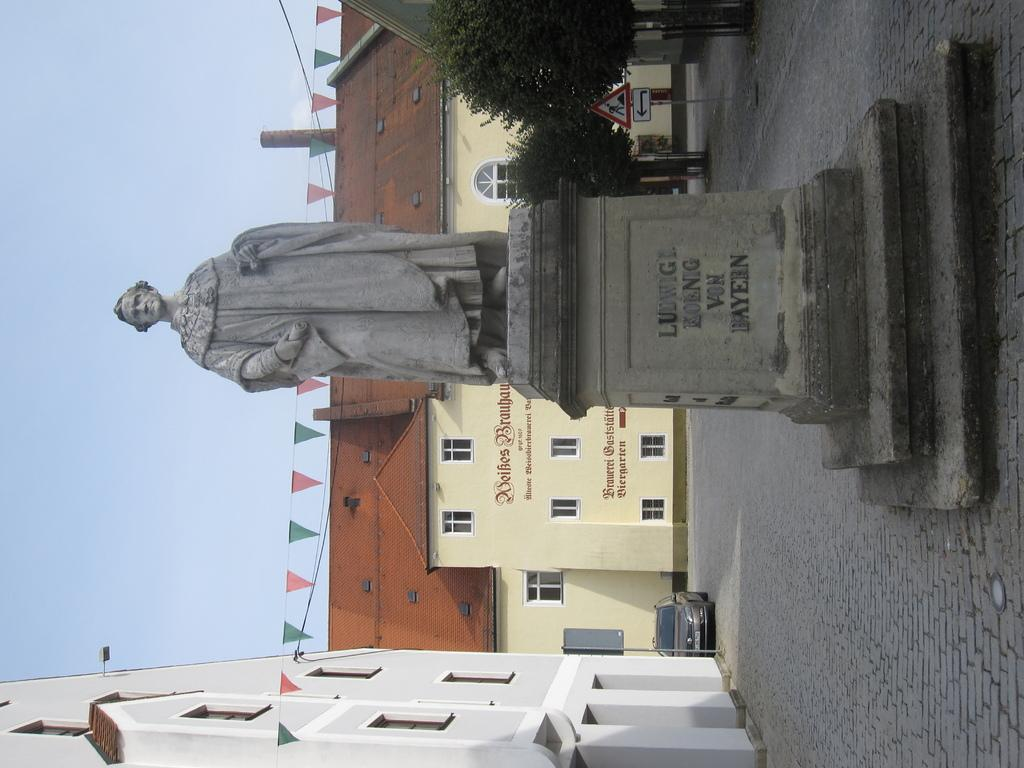<image>
Write a terse but informative summary of the picture. A stone statue of a man says Ludwig Koenig Von Bayern. 